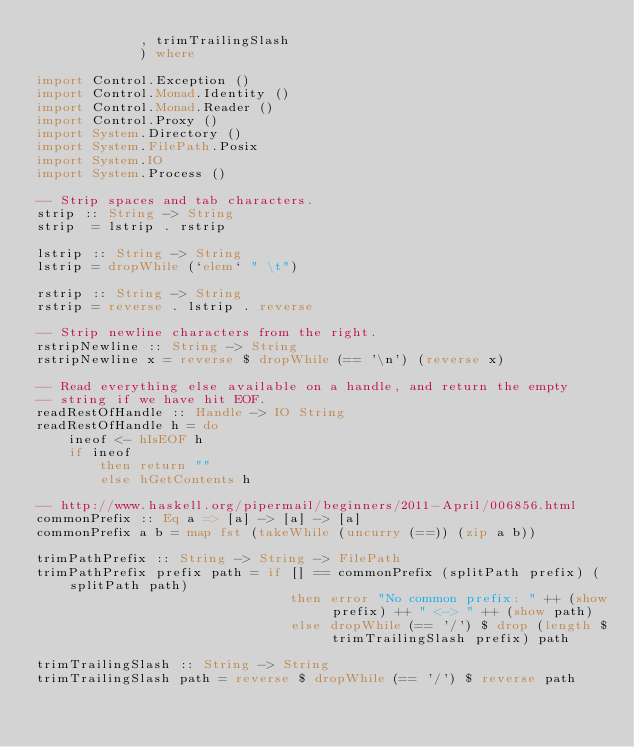Convert code to text. <code><loc_0><loc_0><loc_500><loc_500><_Haskell_>             , trimTrailingSlash 
             ) where

import Control.Exception ()
import Control.Monad.Identity ()
import Control.Monad.Reader ()
import Control.Proxy ()
import System.Directory ()
import System.FilePath.Posix
import System.IO
import System.Process ()

-- Strip spaces and tab characters.
strip :: String -> String
strip  = lstrip . rstrip

lstrip :: String -> String
lstrip = dropWhile (`elem` " \t")

rstrip :: String -> String
rstrip = reverse . lstrip . reverse

-- Strip newline characters from the right.
rstripNewline :: String -> String
rstripNewline x = reverse $ dropWhile (== '\n') (reverse x)

-- Read everything else available on a handle, and return the empty
-- string if we have hit EOF.
readRestOfHandle :: Handle -> IO String
readRestOfHandle h = do
    ineof <- hIsEOF h
    if ineof
        then return ""
        else hGetContents h

-- http://www.haskell.org/pipermail/beginners/2011-April/006856.html
commonPrefix :: Eq a => [a] -> [a] -> [a]
commonPrefix a b = map fst (takeWhile (uncurry (==)) (zip a b))

trimPathPrefix :: String -> String -> FilePath
trimPathPrefix prefix path = if [] == commonPrefix (splitPath prefix) (splitPath path)
                                then error "No common prefix: " ++ (show prefix) ++ " <-> " ++ (show path)
                                else dropWhile (== '/') $ drop (length $ trimTrailingSlash prefix) path

trimTrailingSlash :: String -> String
trimTrailingSlash path = reverse $ dropWhile (== '/') $ reverse path
</code> 